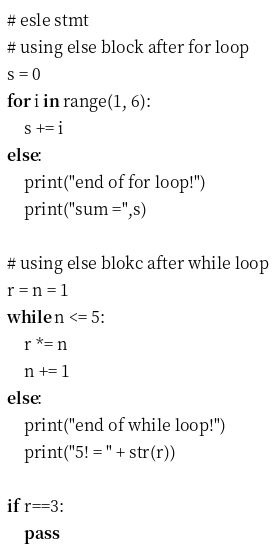<code> <loc_0><loc_0><loc_500><loc_500><_Python_># esle stmt
# using else block after for loop
s = 0
for i in range(1, 6):
    s += i
else:
    print("end of for loop!")
    print("sum =",s)

# using else blokc after while loop
r = n = 1
while n <= 5:
    r *= n
    n += 1
else:
    print("end of while loop!")
    print("5! = " + str(r))

if r==3:
    pass

</code> 